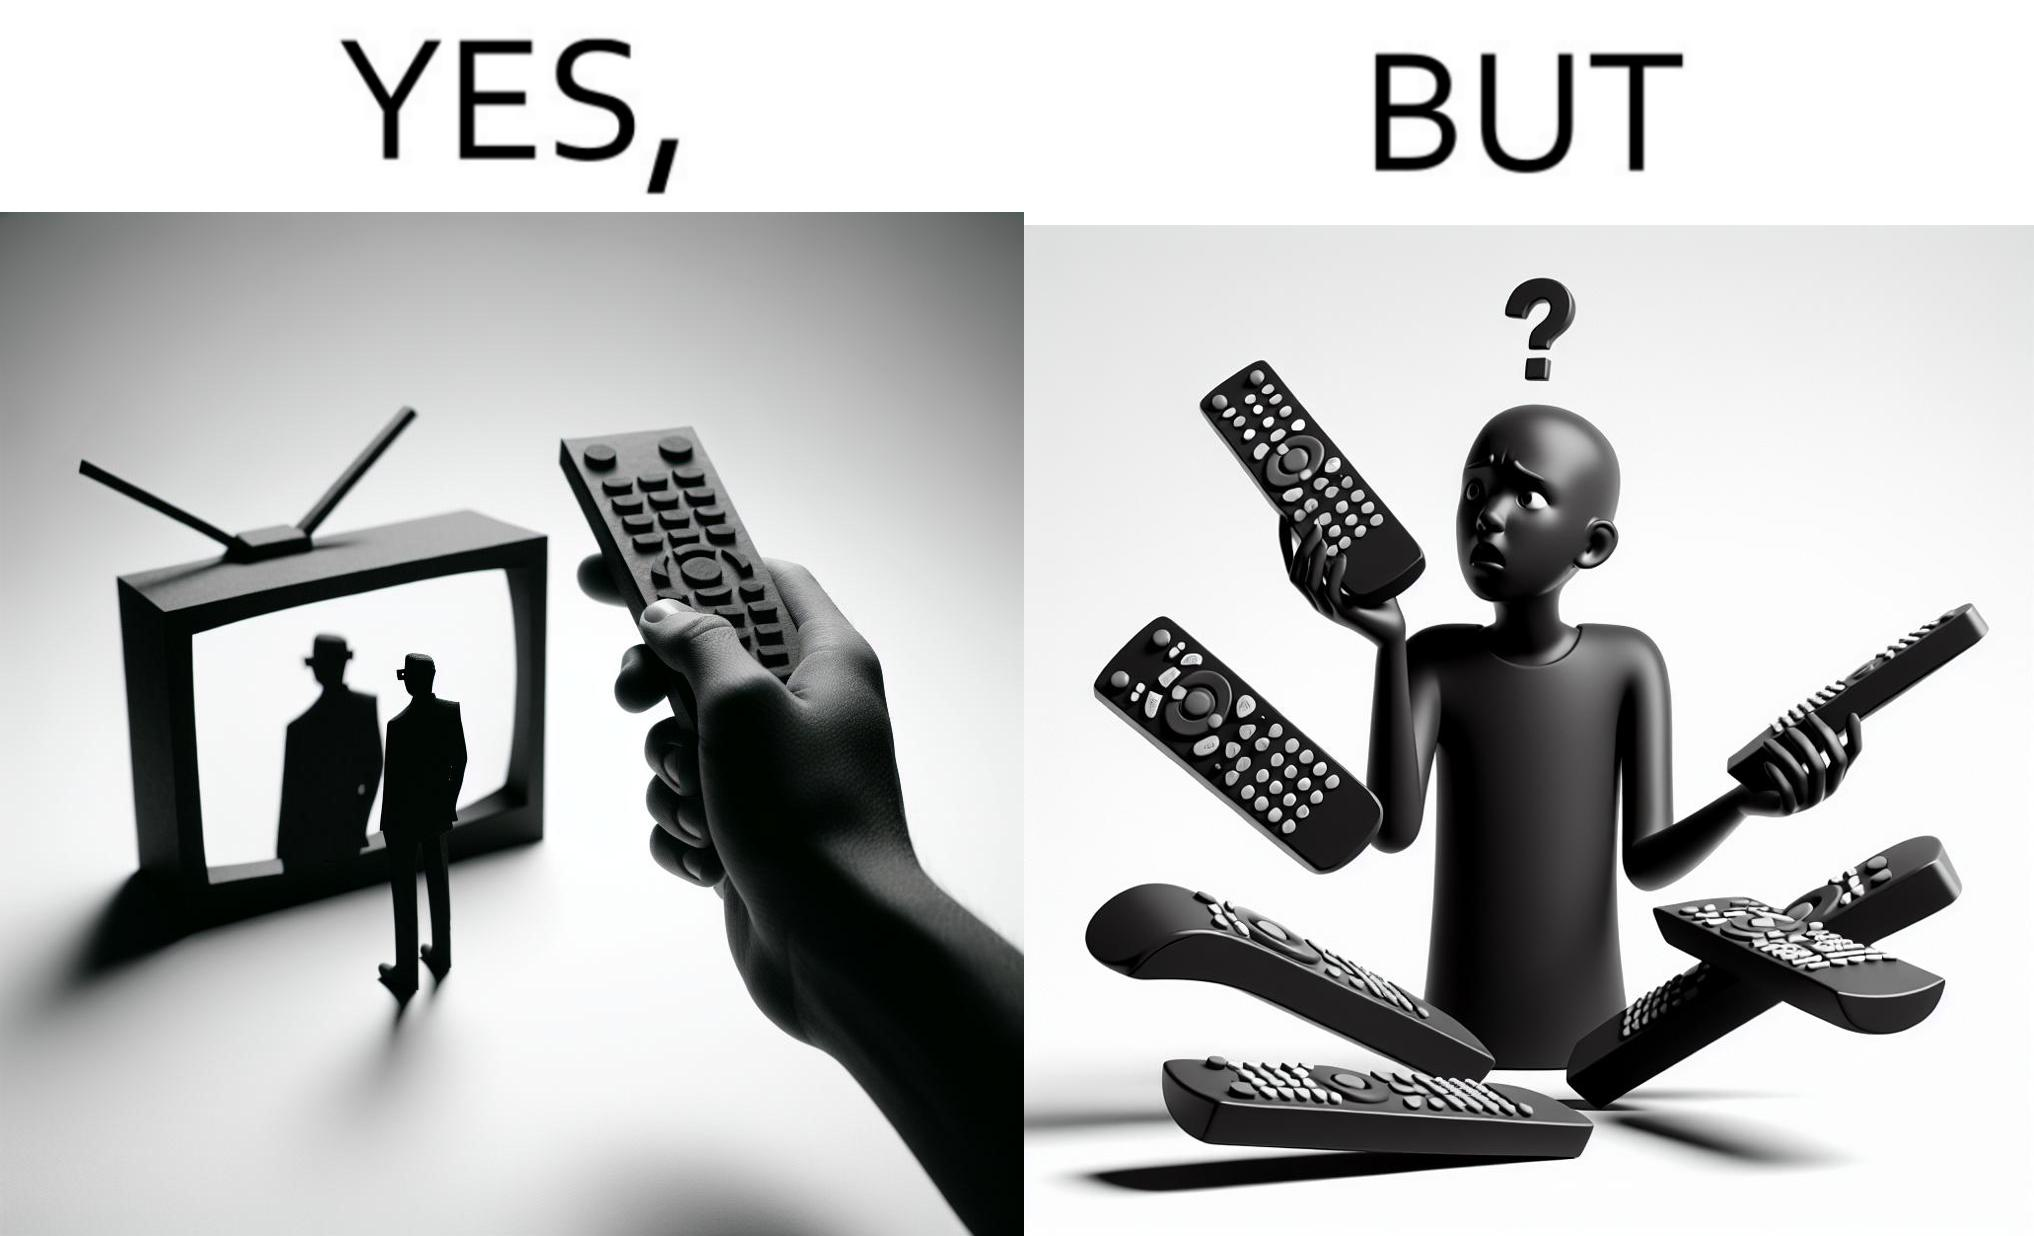Would you classify this image as satirical? Yes, this image is satirical. 